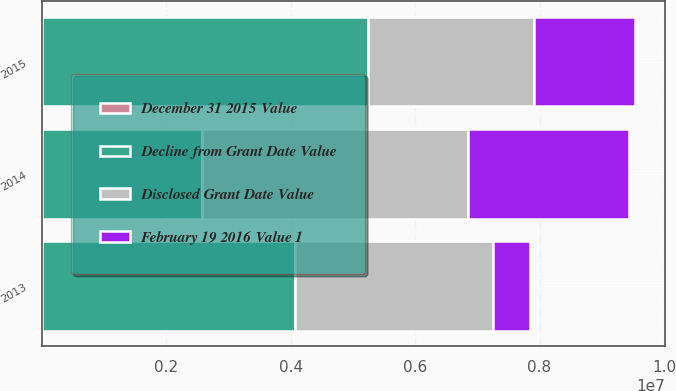<chart> <loc_0><loc_0><loc_500><loc_500><stacked_bar_chart><ecel><fcel>2015<fcel>2014<fcel>2013<nl><fcel>Decline from Grant Date Value<fcel>5.23556e+06<fcel>2.57885e+06<fcel>4.07362e+06<nl><fcel>Disclosed Grant Date Value<fcel>2.68072e+06<fcel>4.27314e+06<fcel>3.18276e+06<nl><fcel>December 31 2015 Value<fcel>49<fcel>48<fcel>22<nl><fcel>February 19 2016 Value 1<fcel>1.61782e+06<fcel>2.57885e+06<fcel>597089<nl></chart> 